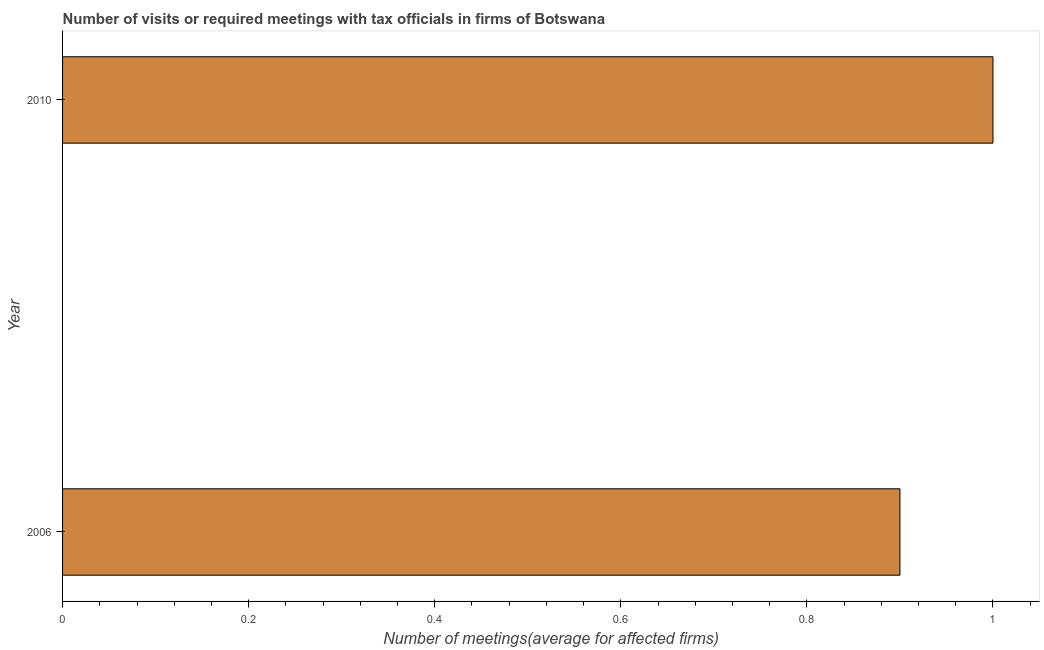What is the title of the graph?
Provide a short and direct response. Number of visits or required meetings with tax officials in firms of Botswana. What is the label or title of the X-axis?
Your answer should be compact. Number of meetings(average for affected firms). What is the label or title of the Y-axis?
Provide a short and direct response. Year. Across all years, what is the maximum number of required meetings with tax officials?
Provide a short and direct response. 1. Across all years, what is the minimum number of required meetings with tax officials?
Offer a very short reply. 0.9. In which year was the number of required meetings with tax officials maximum?
Offer a very short reply. 2010. In which year was the number of required meetings with tax officials minimum?
Offer a very short reply. 2006. In how many years, is the number of required meetings with tax officials greater than 0.76 ?
Provide a short and direct response. 2. Is the number of required meetings with tax officials in 2006 less than that in 2010?
Offer a very short reply. Yes. In how many years, is the number of required meetings with tax officials greater than the average number of required meetings with tax officials taken over all years?
Ensure brevity in your answer.  1. How many bars are there?
Offer a very short reply. 2. Are all the bars in the graph horizontal?
Your answer should be very brief. Yes. What is the difference between two consecutive major ticks on the X-axis?
Keep it short and to the point. 0.2. What is the difference between the Number of meetings(average for affected firms) in 2006 and 2010?
Your answer should be very brief. -0.1. What is the ratio of the Number of meetings(average for affected firms) in 2006 to that in 2010?
Your answer should be very brief. 0.9. 